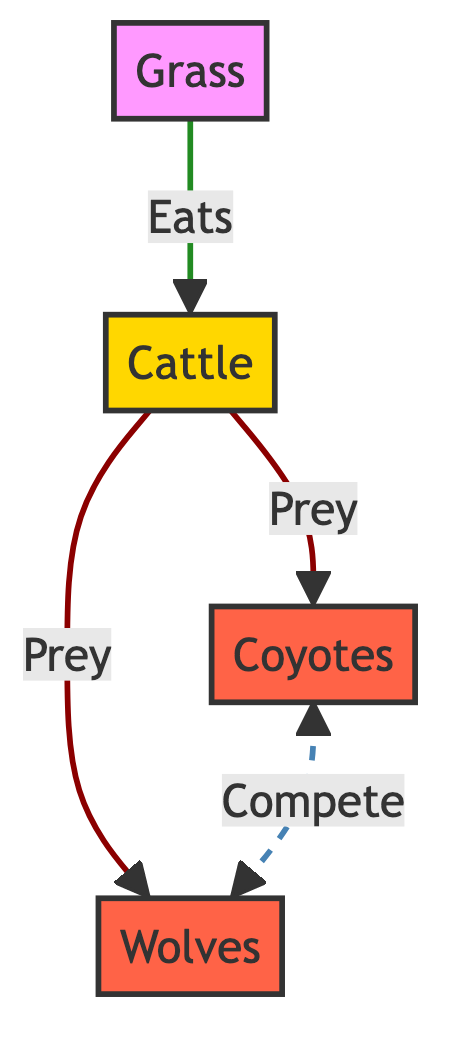What are the three main components of the food chain depicted in the diagram? The diagram shows three main components: Grass, Cattle, and two predators (Coyotes and Wolves). Therefore, those three components are all the identifiable nodes in the food chain.
Answer: Grass, Cattle, Coyotes, Wolves How many predator nodes are present in the diagram? There are two distinct predator nodes highlighted in the diagram: Coyotes and Wolves. Thus, by counting these nodes, the answer is two.
Answer: 2 Which animal is at the top of the food chain in this diagram? The relationship in the diagram indicates that Coyotes and Wolves are the predators, suggesting they are at the top of the food chain. There is no other entity that preys on them, establishing them as top predators.
Answer: Coyotes, Wolves What is the primary source of food for the cattle? In the diagram, Grass is shown to be the entity that Cattle feed on, indicating that Grass is the primary food source for the Cattle population.
Answer: Grass Who competes with the coyotes for food? The diagram indicates a competitive relationship between Coyotes and Wolves, showing that they both vie for similar food sources, likely including Cattle as prey.
Answer: Wolves How many prey relationships are displayed in the diagram? The diagram illustrates two direct prey relationships: Cattle being prey for both Coyotes and Wolves. Thus, adding them gives a total of two prey relationships.
Answer: 2 What role does grass play in this food chain? Grass serves as the foundational producer in this food chain, as it is the food source for Cattle, which in turn are preyed upon by coyotes and wolves. Therefore, Grass can be identified as the primary producer.
Answer: Producer Which predator competes with coyotes for cattle? In the diagram, Wolves are shown as competing with Coyotes, affirming their shared interest in preying on Cattle for sustenance. Thus, it's clear that Wolves are identified as competitors to Coyotes.
Answer: Wolves 